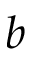Convert formula to latex. <formula><loc_0><loc_0><loc_500><loc_500>b</formula> 